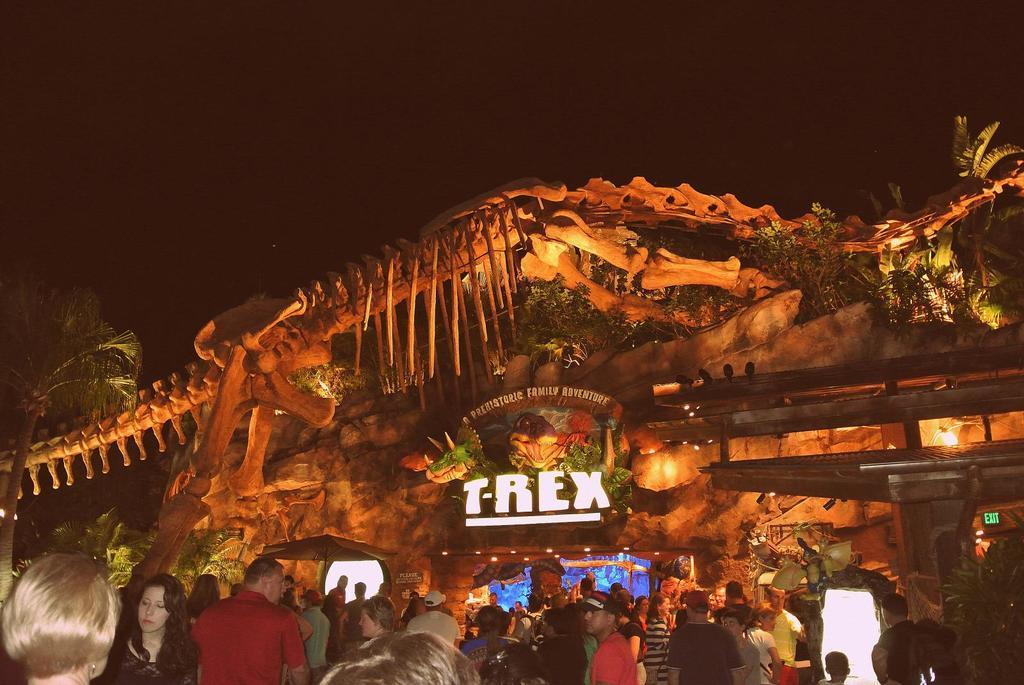Describe this image in one or two sentences. At the bottom of this image, there are persons in different color dresses. Above them, there is a statue of a skeleton of an animal. Beside this statue, there are trees. In the background, there are hoardings, lights, trees, plants and a building. And the background is dark in color. 